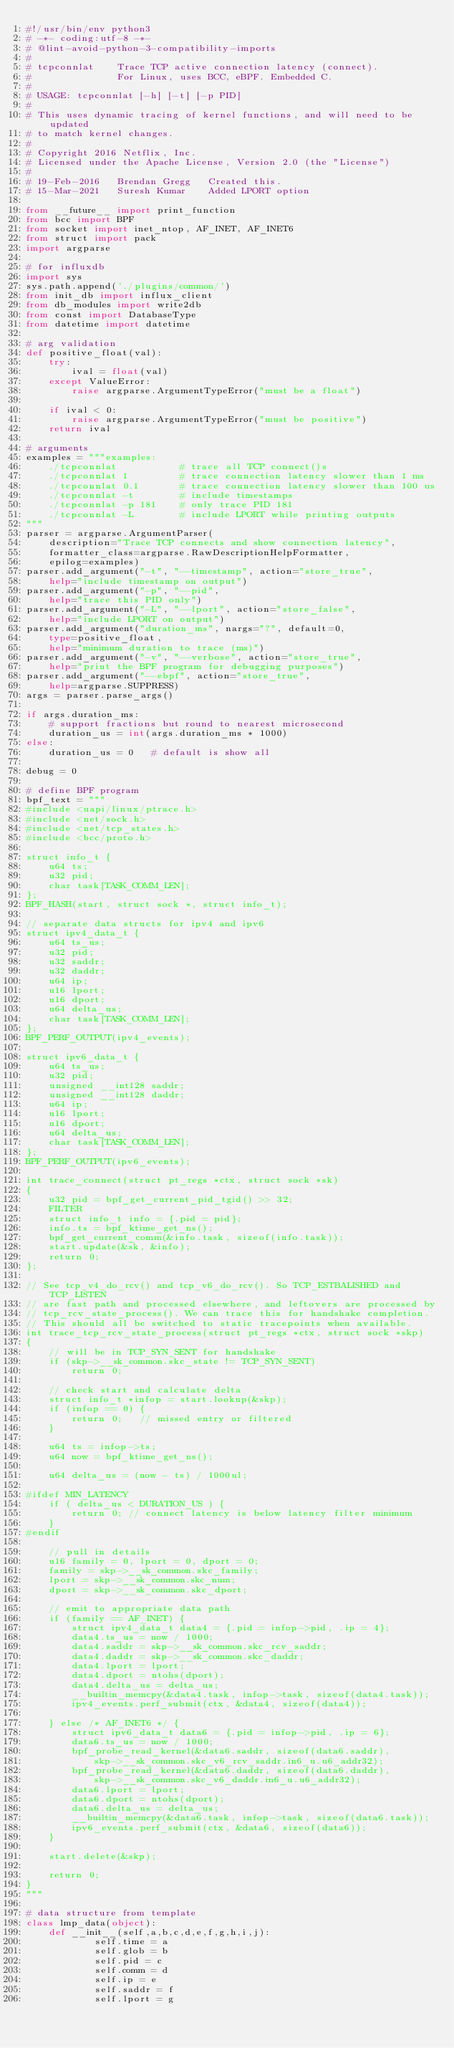<code> <loc_0><loc_0><loc_500><loc_500><_Python_>#!/usr/bin/env python3
# -*- coding:utf-8 -*-
# @lint-avoid-python-3-compatibility-imports
#
# tcpconnlat    Trace TCP active connection latency (connect).
#               For Linux, uses BCC, eBPF. Embedded C.
#
# USAGE: tcpconnlat [-h] [-t] [-p PID]
#
# This uses dynamic tracing of kernel functions, and will need to be updated
# to match kernel changes.
#
# Copyright 2016 Netflix, Inc.
# Licensed under the Apache License, Version 2.0 (the "License")
#
# 19-Feb-2016   Brendan Gregg   Created this.
# 15-Mar-2021   Suresh Kumar    Added LPORT option

from __future__ import print_function
from bcc import BPF
from socket import inet_ntop, AF_INET, AF_INET6
from struct import pack
import argparse

# for influxdb
import sys
sys.path.append('./plugins/common/')
from init_db import influx_client
from db_modules import write2db
from const import DatabaseType
from datetime import datetime

# arg validation
def positive_float(val):
    try:
        ival = float(val)
    except ValueError:
        raise argparse.ArgumentTypeError("must be a float")

    if ival < 0:
        raise argparse.ArgumentTypeError("must be positive")
    return ival

# arguments
examples = """examples:
    ./tcpconnlat           # trace all TCP connect()s
    ./tcpconnlat 1         # trace connection latency slower than 1 ms
    ./tcpconnlat 0.1       # trace connection latency slower than 100 us
    ./tcpconnlat -t        # include timestamps
    ./tcpconnlat -p 181    # only trace PID 181
    ./tcpconnlat -L        # include LPORT while printing outputs
"""
parser = argparse.ArgumentParser(
    description="Trace TCP connects and show connection latency",
    formatter_class=argparse.RawDescriptionHelpFormatter,
    epilog=examples)
parser.add_argument("-t", "--timestamp", action="store_true",
    help="include timestamp on output")
parser.add_argument("-p", "--pid",
    help="trace this PID only")
parser.add_argument("-L", "--lport", action="store_false",
    help="include LPORT on output")
parser.add_argument("duration_ms", nargs="?", default=0,
    type=positive_float,
    help="minimum duration to trace (ms)")
parser.add_argument("-v", "--verbose", action="store_true",
    help="print the BPF program for debugging purposes")
parser.add_argument("--ebpf", action="store_true",
    help=argparse.SUPPRESS)
args = parser.parse_args()

if args.duration_ms:
    # support fractions but round to nearest microsecond
    duration_us = int(args.duration_ms * 1000)
else:
    duration_us = 0   # default is show all

debug = 0

# define BPF program
bpf_text = """
#include <uapi/linux/ptrace.h>
#include <net/sock.h>
#include <net/tcp_states.h>
#include <bcc/proto.h>

struct info_t {
    u64 ts;
    u32 pid;
    char task[TASK_COMM_LEN];
};
BPF_HASH(start, struct sock *, struct info_t);

// separate data structs for ipv4 and ipv6
struct ipv4_data_t {
    u64 ts_us;
    u32 pid;
    u32 saddr;
    u32 daddr;
    u64 ip;
    u16 lport;
    u16 dport;
    u64 delta_us;
    char task[TASK_COMM_LEN];
};
BPF_PERF_OUTPUT(ipv4_events);

struct ipv6_data_t {
    u64 ts_us;
    u32 pid;
    unsigned __int128 saddr;
    unsigned __int128 daddr;
    u64 ip;
    u16 lport;
    u16 dport;
    u64 delta_us;
    char task[TASK_COMM_LEN];
};
BPF_PERF_OUTPUT(ipv6_events);

int trace_connect(struct pt_regs *ctx, struct sock *sk)
{
    u32 pid = bpf_get_current_pid_tgid() >> 32;
    FILTER
    struct info_t info = {.pid = pid};
    info.ts = bpf_ktime_get_ns();
    bpf_get_current_comm(&info.task, sizeof(info.task));
    start.update(&sk, &info);
    return 0;
};

// See tcp_v4_do_rcv() and tcp_v6_do_rcv(). So TCP_ESTBALISHED and TCP_LISTEN
// are fast path and processed elsewhere, and leftovers are processed by
// tcp_rcv_state_process(). We can trace this for handshake completion.
// This should all be switched to static tracepoints when available.
int trace_tcp_rcv_state_process(struct pt_regs *ctx, struct sock *skp)
{
    // will be in TCP_SYN_SENT for handshake
    if (skp->__sk_common.skc_state != TCP_SYN_SENT)
        return 0;

    // check start and calculate delta
    struct info_t *infop = start.lookup(&skp);
    if (infop == 0) {
        return 0;   // missed entry or filtered
    }

    u64 ts = infop->ts;
    u64 now = bpf_ktime_get_ns();

    u64 delta_us = (now - ts) / 1000ul;

#ifdef MIN_LATENCY
    if ( delta_us < DURATION_US ) {
        return 0; // connect latency is below latency filter minimum
    }
#endif

    // pull in details
    u16 family = 0, lport = 0, dport = 0;
    family = skp->__sk_common.skc_family;
    lport = skp->__sk_common.skc_num;
    dport = skp->__sk_common.skc_dport;

    // emit to appropriate data path
    if (family == AF_INET) {
        struct ipv4_data_t data4 = {.pid = infop->pid, .ip = 4};
        data4.ts_us = now / 1000;
        data4.saddr = skp->__sk_common.skc_rcv_saddr;
        data4.daddr = skp->__sk_common.skc_daddr;
        data4.lport = lport;
        data4.dport = ntohs(dport);
        data4.delta_us = delta_us;
        __builtin_memcpy(&data4.task, infop->task, sizeof(data4.task));
        ipv4_events.perf_submit(ctx, &data4, sizeof(data4));

    } else /* AF_INET6 */ {
        struct ipv6_data_t data6 = {.pid = infop->pid, .ip = 6};
        data6.ts_us = now / 1000;
        bpf_probe_read_kernel(&data6.saddr, sizeof(data6.saddr),
            skp->__sk_common.skc_v6_rcv_saddr.in6_u.u6_addr32);
        bpf_probe_read_kernel(&data6.daddr, sizeof(data6.daddr),
            skp->__sk_common.skc_v6_daddr.in6_u.u6_addr32);
        data6.lport = lport;
        data6.dport = ntohs(dport);
        data6.delta_us = delta_us;
        __builtin_memcpy(&data6.task, infop->task, sizeof(data6.task));
        ipv6_events.perf_submit(ctx, &data6, sizeof(data6));
    }

    start.delete(&skp);

    return 0;
}
"""

# data structure from template
class lmp_data(object):
    def __init__(self,a,b,c,d,e,f,g,h,i,j):
            self.time = a
            self.glob = b
            self.pid = c
            self.comm = d
            self.ip = e
            self.saddr = f
            self.lport = g</code> 